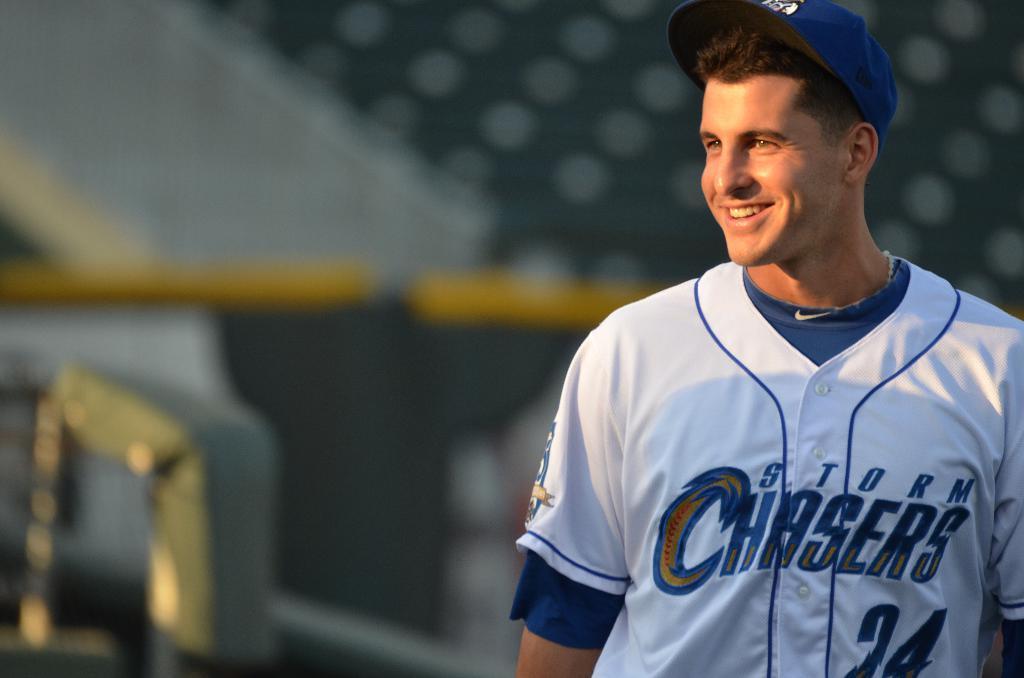Could you give a brief overview of what you see in this image? In this image in the front there is a man standing and smiling and the background is blurry. 